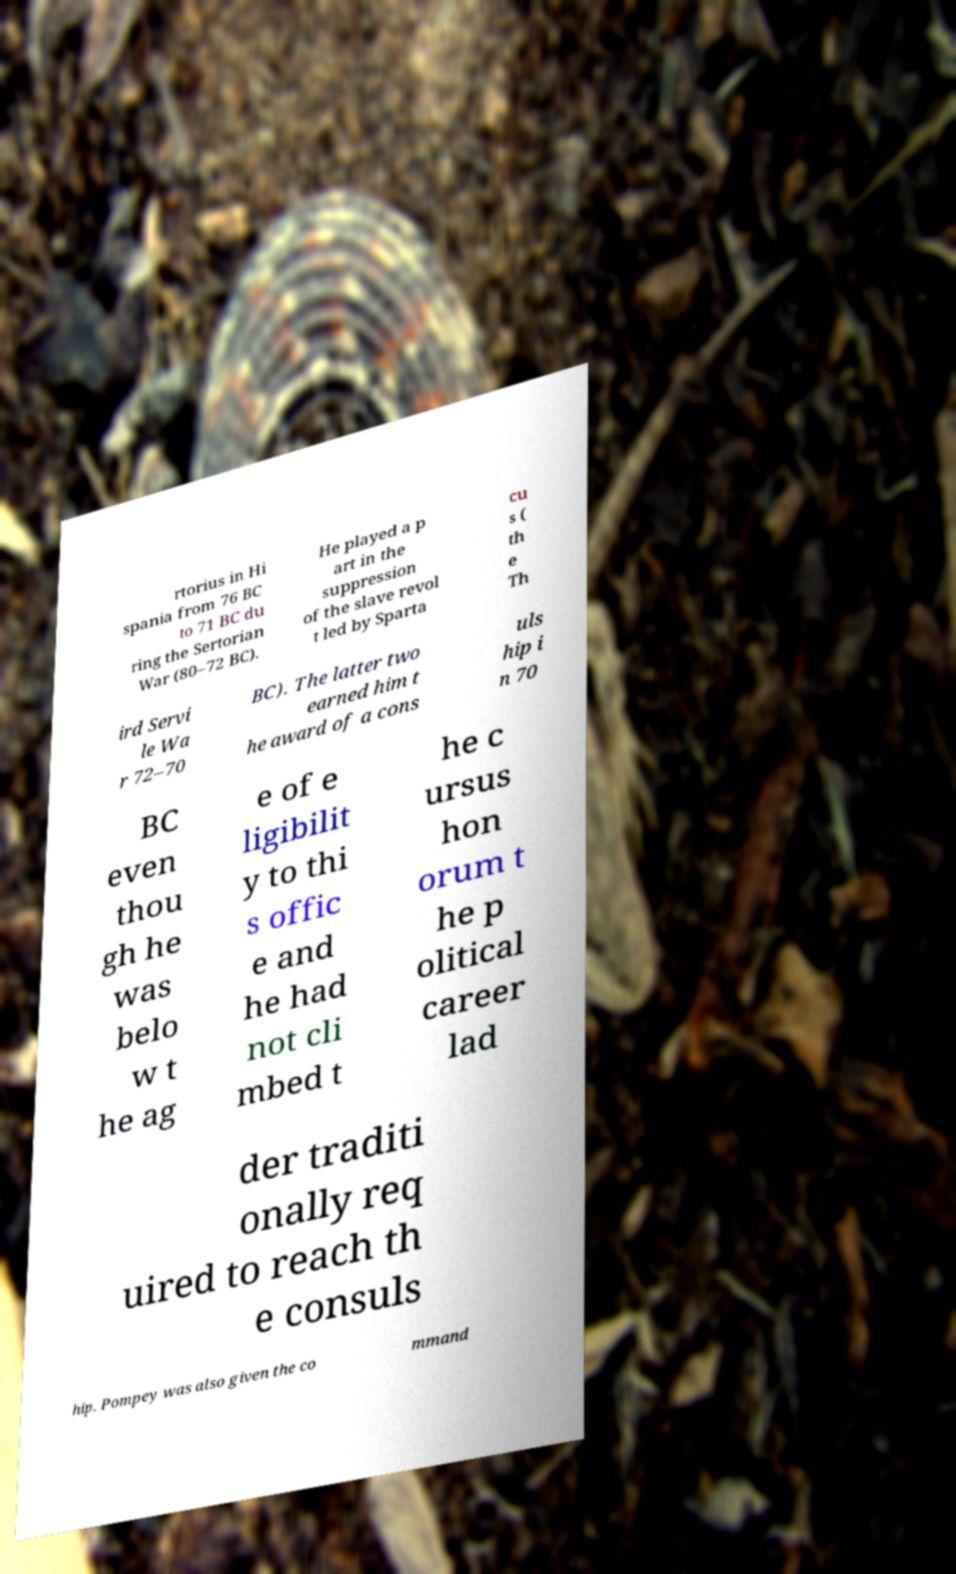Please read and relay the text visible in this image. What does it say? rtorius in Hi spania from 76 BC to 71 BC du ring the Sertorian War (80–72 BC). He played a p art in the suppression of the slave revol t led by Sparta cu s ( th e Th ird Servi le Wa r 72–70 BC). The latter two earned him t he award of a cons uls hip i n 70 BC even thou gh he was belo w t he ag e of e ligibilit y to thi s offic e and he had not cli mbed t he c ursus hon orum t he p olitical career lad der traditi onally req uired to reach th e consuls hip. Pompey was also given the co mmand 